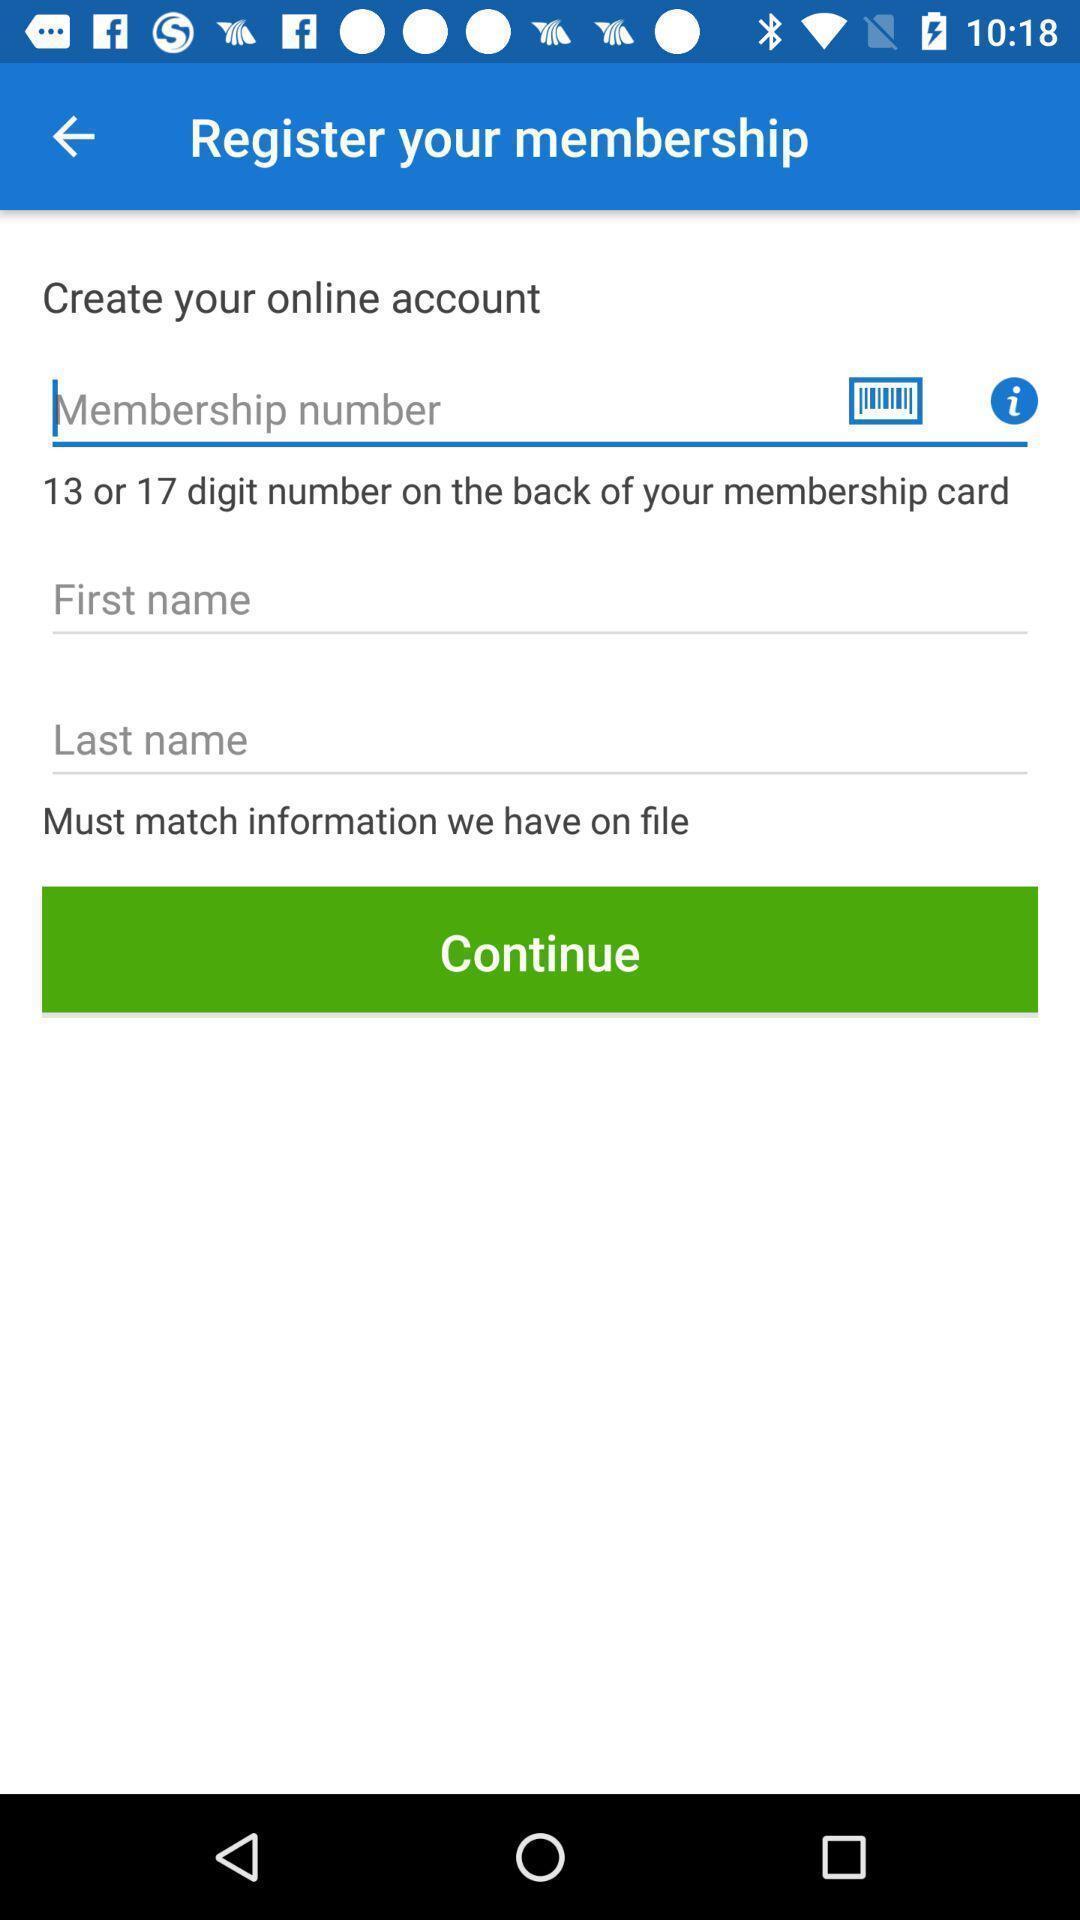Give me a narrative description of this picture. Screen shows register options. 